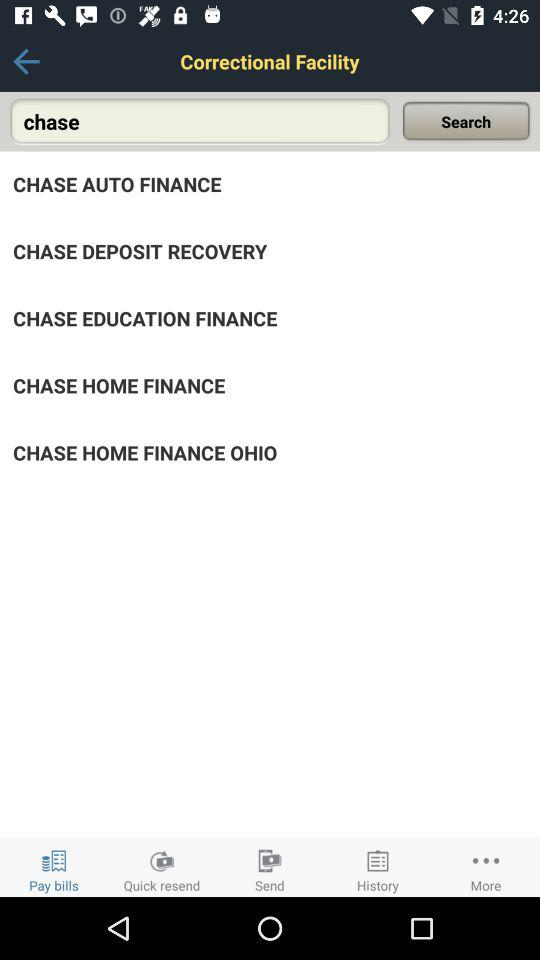What is the input text entered in the search bar? The input text entered in the search bar is "chase". 